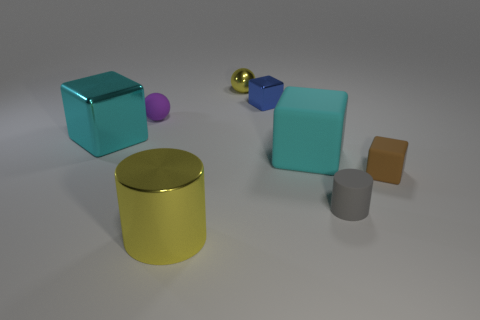Add 1 small cyan things. How many objects exist? 9 Subtract all cylinders. How many objects are left? 6 Subtract 0 red balls. How many objects are left? 8 Subtract all tiny purple cubes. Subtract all large yellow things. How many objects are left? 7 Add 5 brown objects. How many brown objects are left? 6 Add 4 small blue cubes. How many small blue cubes exist? 5 